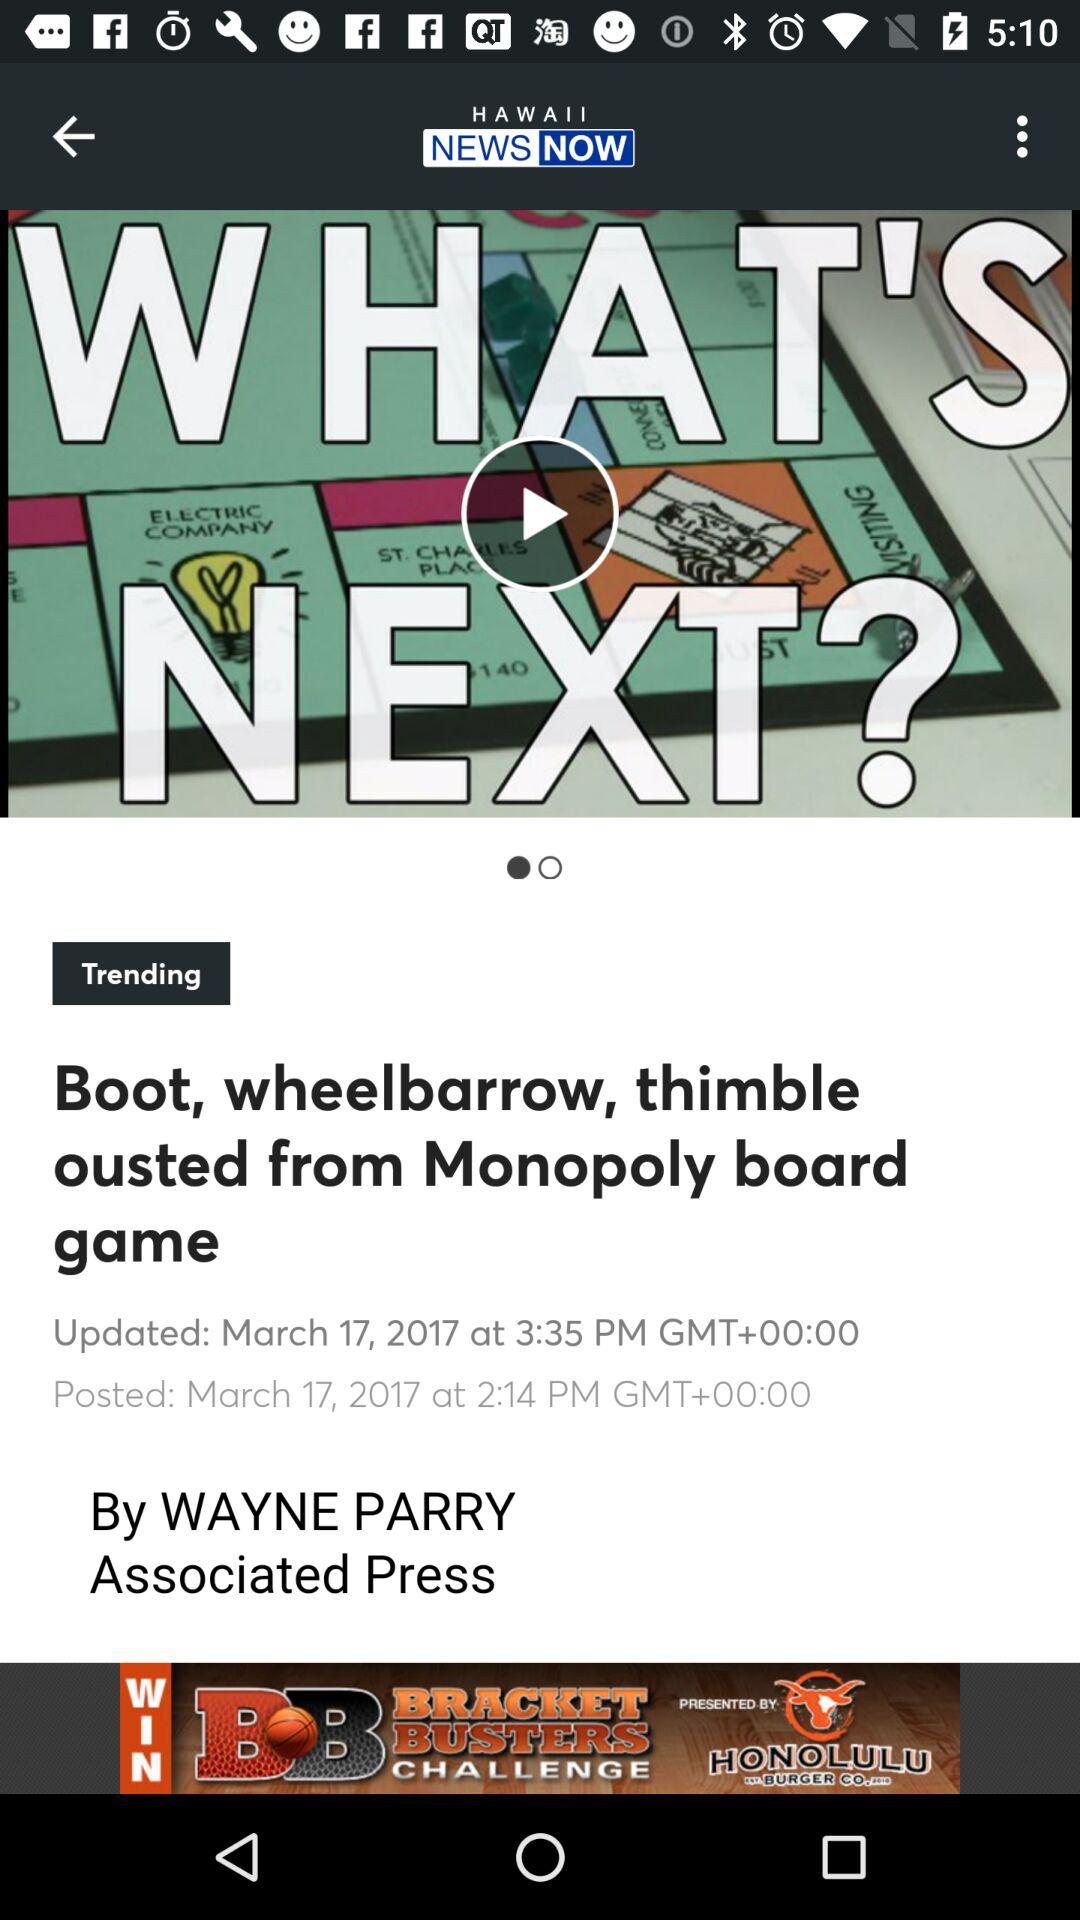What is the posted date? The posted date is March 17, 2017. 